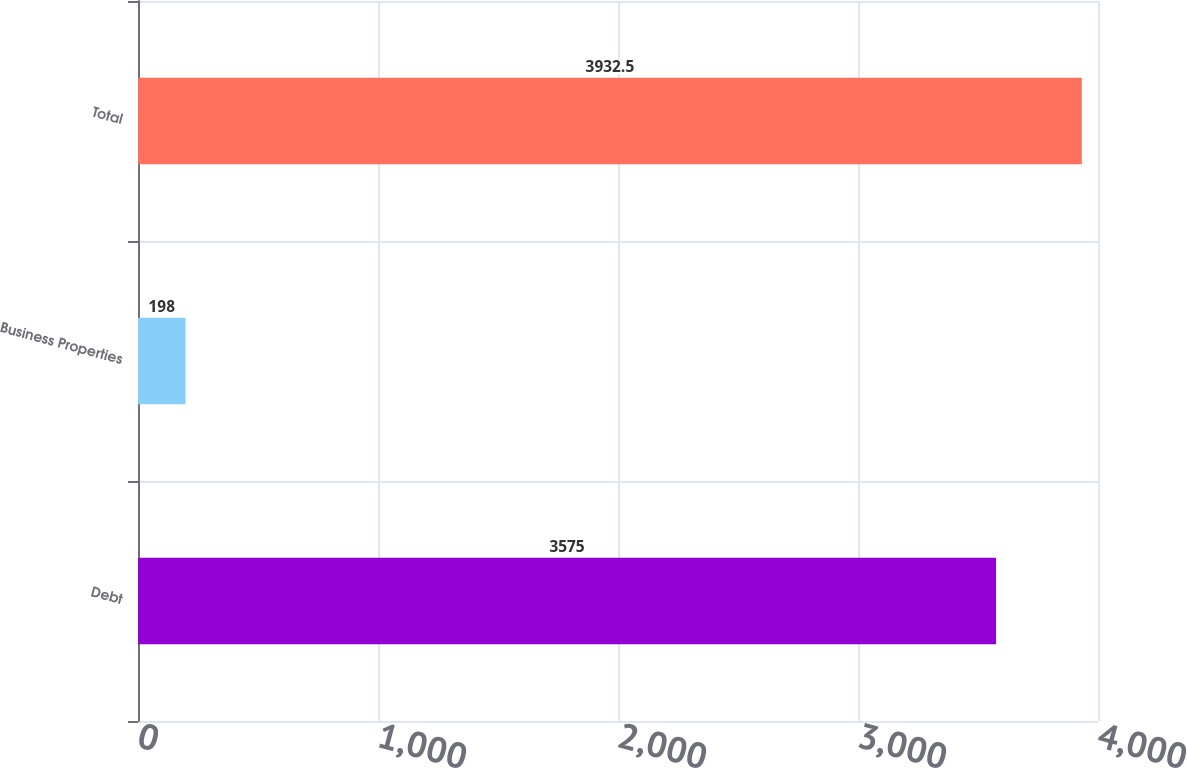Convert chart. <chart><loc_0><loc_0><loc_500><loc_500><bar_chart><fcel>Debt<fcel>Business Properties<fcel>Total<nl><fcel>3575<fcel>198<fcel>3932.5<nl></chart> 